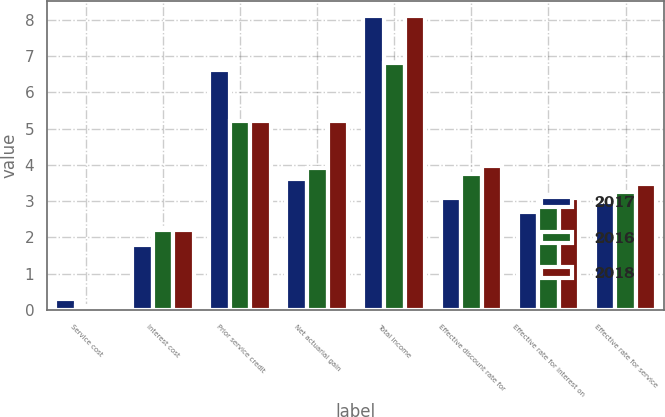<chart> <loc_0><loc_0><loc_500><loc_500><stacked_bar_chart><ecel><fcel>Service cost<fcel>Interest cost<fcel>Prior service credit<fcel>Net actuarial gain<fcel>Total income<fcel>Effective discount rate for<fcel>Effective rate for interest on<fcel>Effective rate for service<nl><fcel>2017<fcel>0.3<fcel>1.8<fcel>6.6<fcel>3.6<fcel>8.1<fcel>3.09<fcel>2.71<fcel>2.98<nl><fcel>2016<fcel>0.1<fcel>2.2<fcel>5.2<fcel>3.9<fcel>6.8<fcel>3.76<fcel>3.07<fcel>3.25<nl><fcel>2018<fcel>0.1<fcel>2.2<fcel>5.2<fcel>5.2<fcel>8.1<fcel>3.97<fcel>3.1<fcel>3.46<nl></chart> 